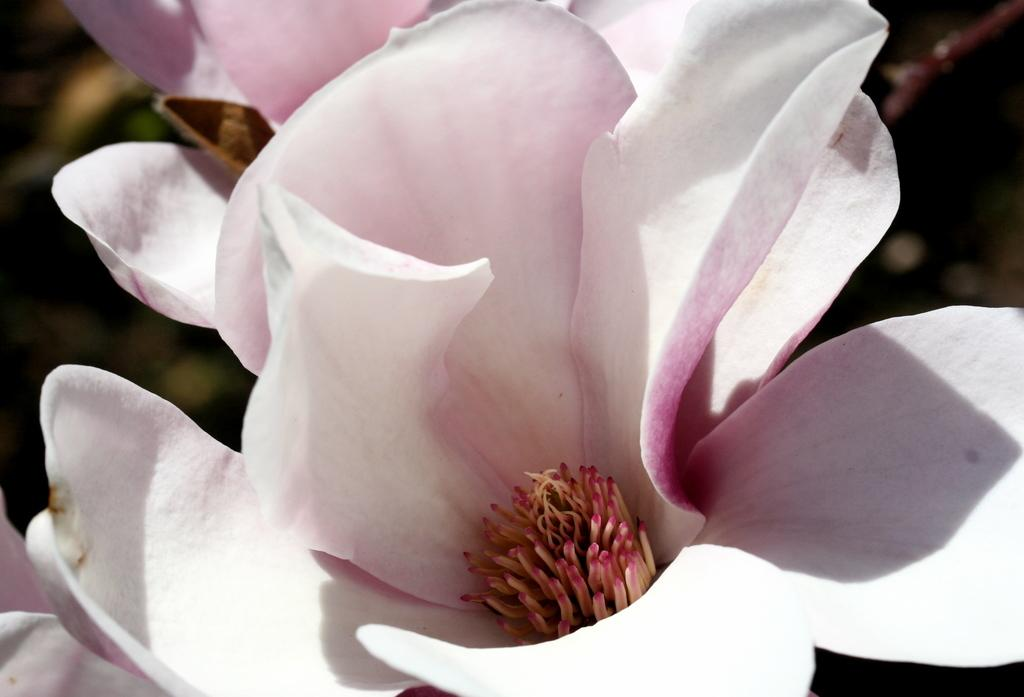What is the main subject of the image? There is a flower in the image. How does the flower compare to a chess piece in the image? There is no chess piece present in the image, so it is not possible to make a comparison. 